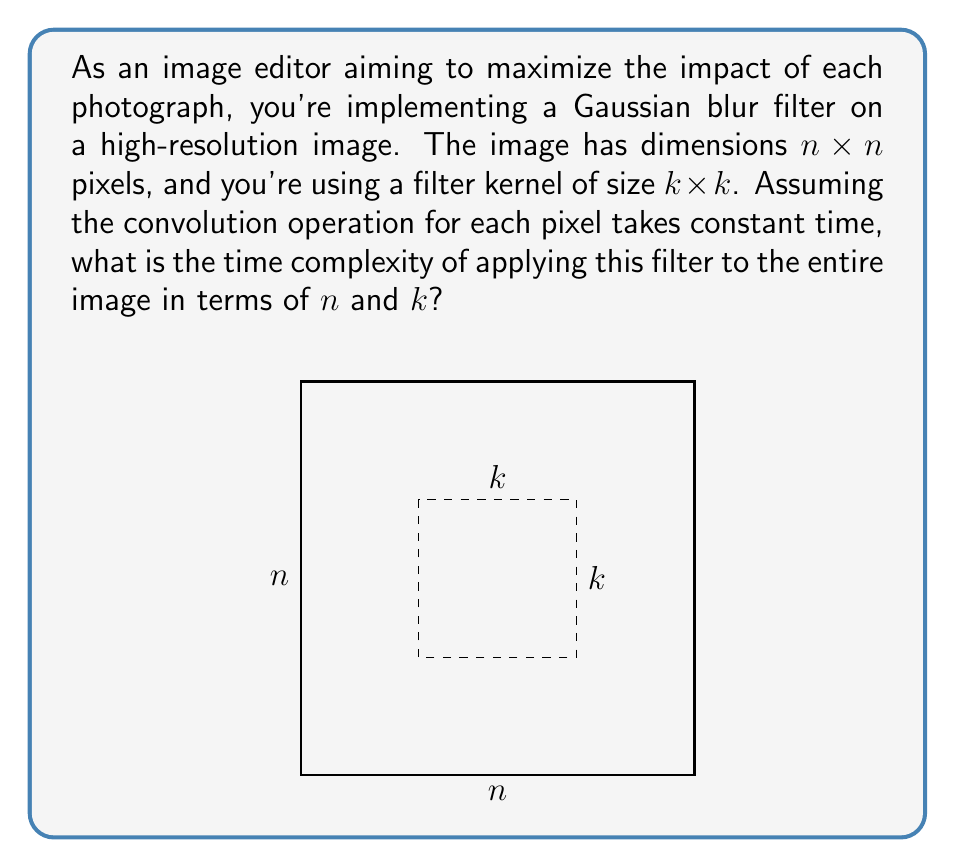Provide a solution to this math problem. Let's break this down step-by-step:

1) The Gaussian blur filter is applied to each pixel in the image. The number of pixels in an $n \times n$ image is $n^2$.

2) For each pixel, we need to perform a convolution operation with the $k \times k$ filter kernel. This involves:
   a) Multiplying each value in the $k \times k$ neighborhood around the pixel with the corresponding value in the filter kernel.
   b) Summing up all these products.

3) The convolution operation for each pixel involves $k^2$ multiplications and additions. However, we're told that this operation takes constant time regardless of $k$.

4) Therefore, for each pixel, we perform a constant time operation.

5) We need to do this for all $n^2$ pixels in the image.

6) Thus, the total time complexity is proportional to the number of pixels: $O(n^2)$.

Note that while $k$ affects the actual running time, it doesn't affect the asymptotic time complexity as $n$ grows, assuming $k$ remains fixed.
Answer: $O(n^2)$ 